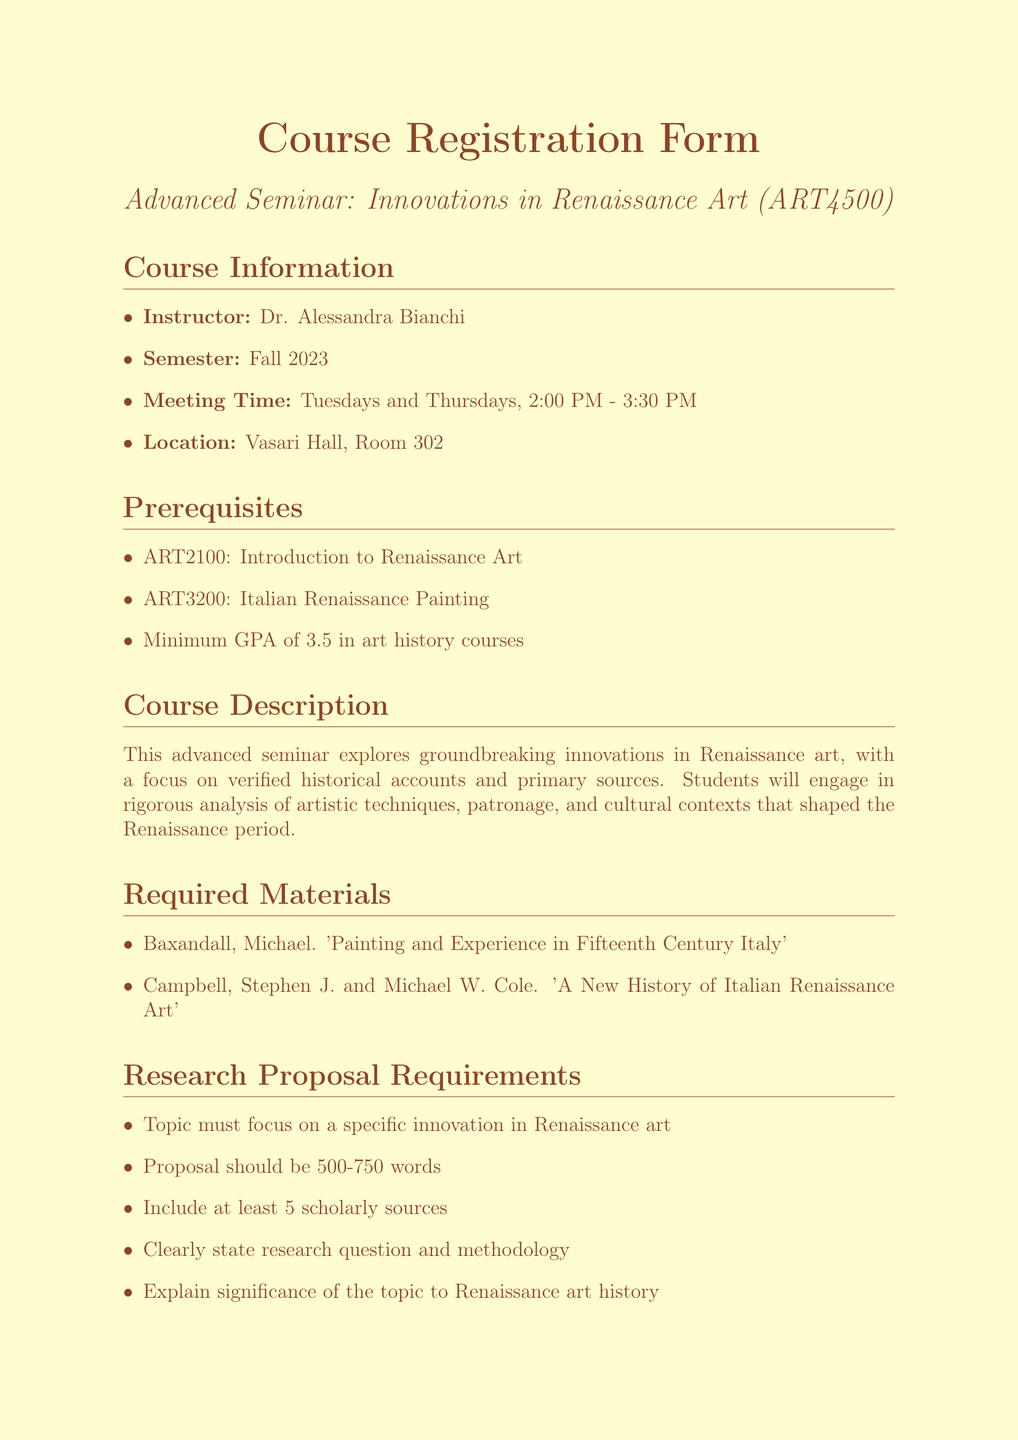What is the course title? The course title is listed at the beginning of the document as "Advanced Seminar: Innovations in Renaissance Art."
Answer: Advanced Seminar: Innovations in Renaissance Art Who is the instructor? The instructor's name is presented in the course information section of the document.
Answer: Dr. Alessandra Bianchi What is the enrollment limit for the seminar? The enrollment limit is stated clearly towards the end of the document.
Answer: 15 What are the prerequisites for the course? The prerequisites are listed as a series of items, which can be found in their own section of the document.
Answer: ART2100: Introduction to Renaissance Art, ART3200: Italian Renaissance Painting, Minimum GPA of 3.5 in art history courses What is the application deadline? The application deadline is mentioned in the important information section of the document.
Answer: August 15, 2023 What is the required length for the research proposal? The required length for the research proposal is specified among the proposal requirements in the document.
Answer: 500-750 words What two materials are required for the course? The required materials are outlined in a separate section, which lists specific books.
Answer: Painting and Experience in Fifteenth Century Italy, A New History of Italian Renaissance Art What publication format is required for the writing sample? The document indicates the necessity of a writing sample from a previous art history course.
Answer: Previous art history course 